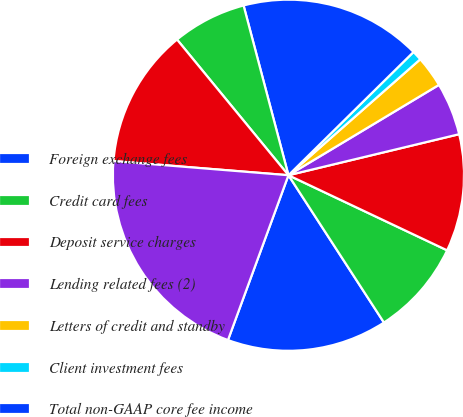Convert chart. <chart><loc_0><loc_0><loc_500><loc_500><pie_chart><fcel>Foreign exchange fees<fcel>Credit card fees<fcel>Deposit service charges<fcel>Lending related fees (2)<fcel>Letters of credit and standby<fcel>Client investment fees<fcel>Total non-GAAP core fee income<fcel>Gains on derivative<fcel>Other<fcel>GAAP noninterest income<nl><fcel>14.75%<fcel>8.81%<fcel>10.79%<fcel>4.85%<fcel>2.88%<fcel>0.9%<fcel>16.73%<fcel>6.83%<fcel>12.77%<fcel>20.69%<nl></chart> 